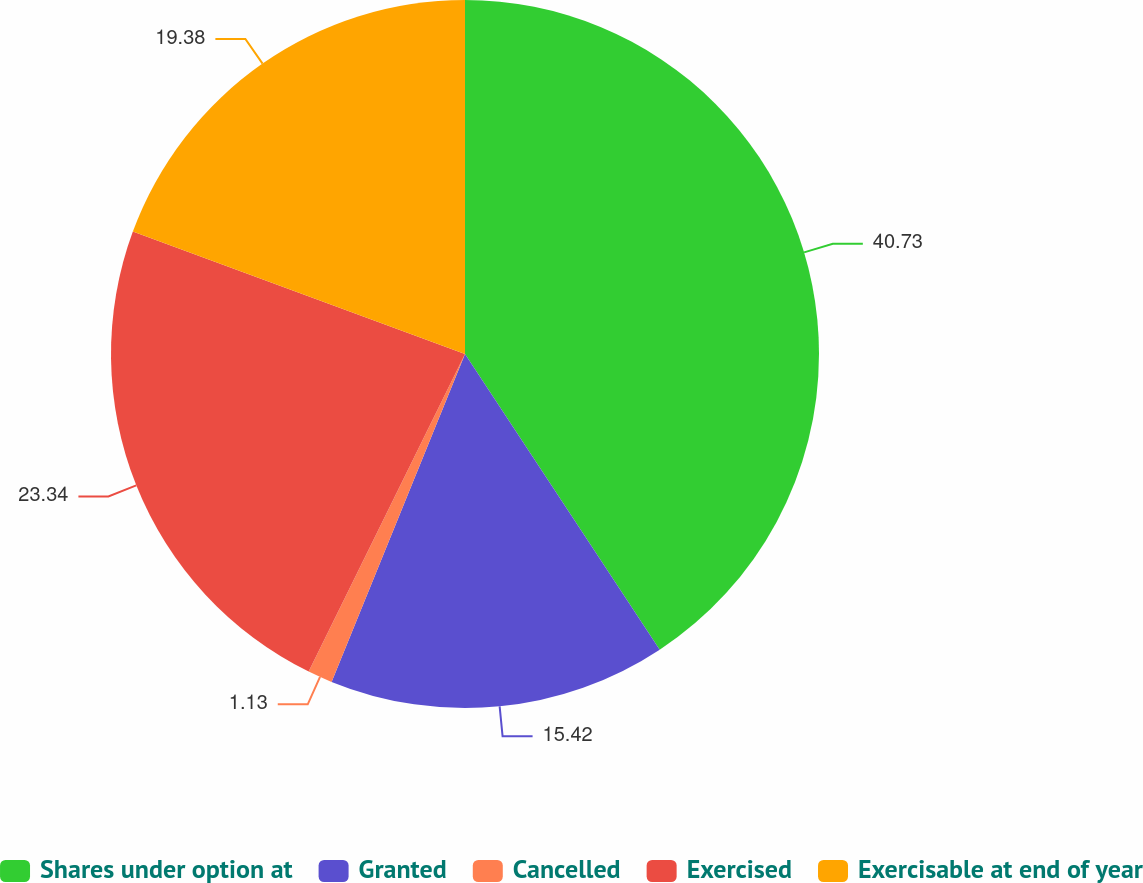Convert chart. <chart><loc_0><loc_0><loc_500><loc_500><pie_chart><fcel>Shares under option at<fcel>Granted<fcel>Cancelled<fcel>Exercised<fcel>Exercisable at end of year<nl><fcel>40.73%<fcel>15.42%<fcel>1.13%<fcel>23.34%<fcel>19.38%<nl></chart> 